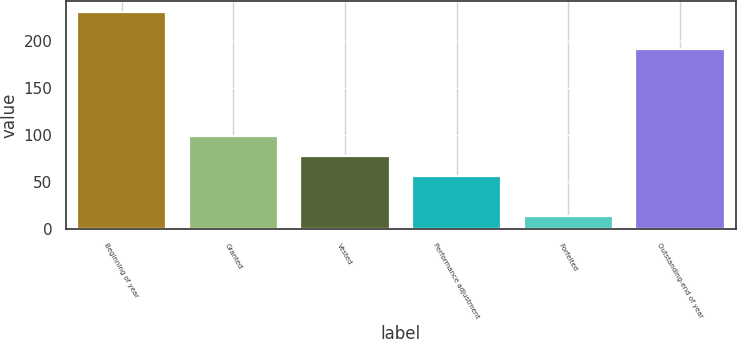Convert chart. <chart><loc_0><loc_0><loc_500><loc_500><bar_chart><fcel>Beginning of year<fcel>Granted<fcel>Vested<fcel>Performance adjustment<fcel>Forfeited<fcel>Outstanding-end of year<nl><fcel>231<fcel>99.4<fcel>77.7<fcel>56<fcel>14<fcel>192<nl></chart> 